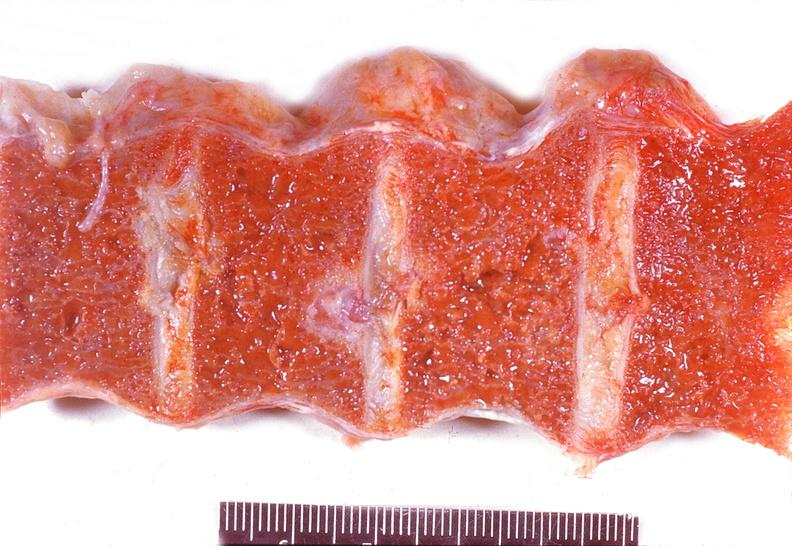what does this image show?
Answer the question using a single word or phrase. Vertebral column 